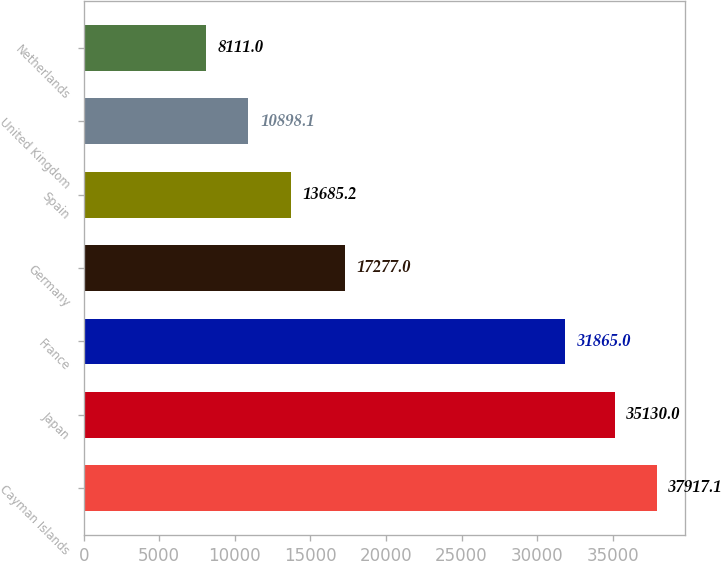<chart> <loc_0><loc_0><loc_500><loc_500><bar_chart><fcel>Cayman Islands<fcel>Japan<fcel>France<fcel>Germany<fcel>Spain<fcel>United Kingdom<fcel>Netherlands<nl><fcel>37917.1<fcel>35130<fcel>31865<fcel>17277<fcel>13685.2<fcel>10898.1<fcel>8111<nl></chart> 